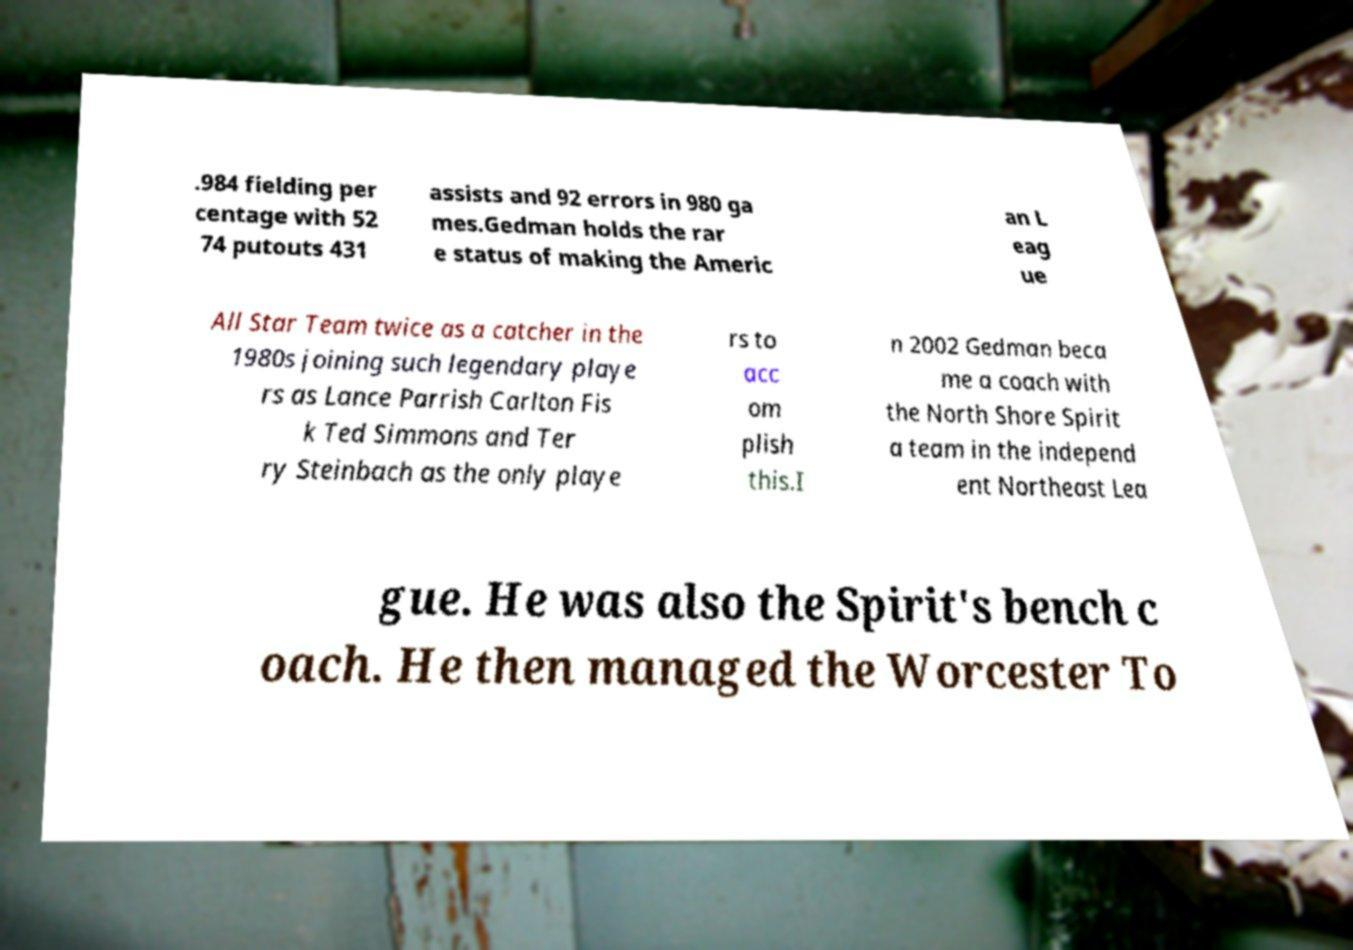Can you read and provide the text displayed in the image?This photo seems to have some interesting text. Can you extract and type it out for me? .984 fielding per centage with 52 74 putouts 431 assists and 92 errors in 980 ga mes.Gedman holds the rar e status of making the Americ an L eag ue All Star Team twice as a catcher in the 1980s joining such legendary playe rs as Lance Parrish Carlton Fis k Ted Simmons and Ter ry Steinbach as the only playe rs to acc om plish this.I n 2002 Gedman beca me a coach with the North Shore Spirit a team in the independ ent Northeast Lea gue. He was also the Spirit's bench c oach. He then managed the Worcester To 